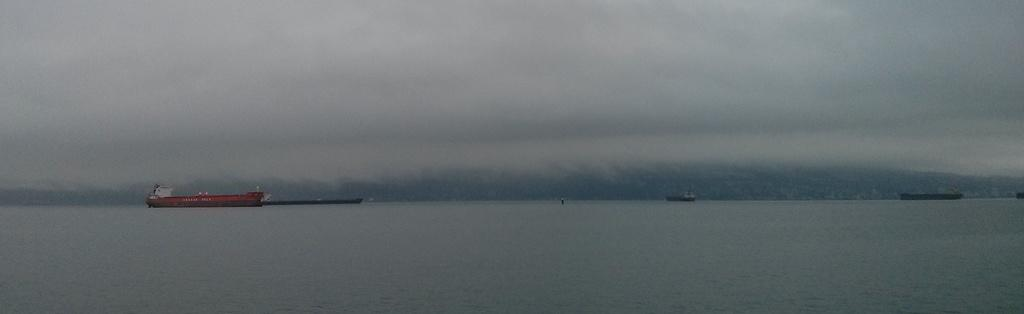What is the main subject of the image? The main subject of the image is ships. Can you describe the position of the ships in the image? The ships are above the water in the image. What can be seen in the background of the image? There is sky visible in the background of the image. What degree does the governor have in the image? There is no governor present in the image, so it is not possible to determine their degree. 